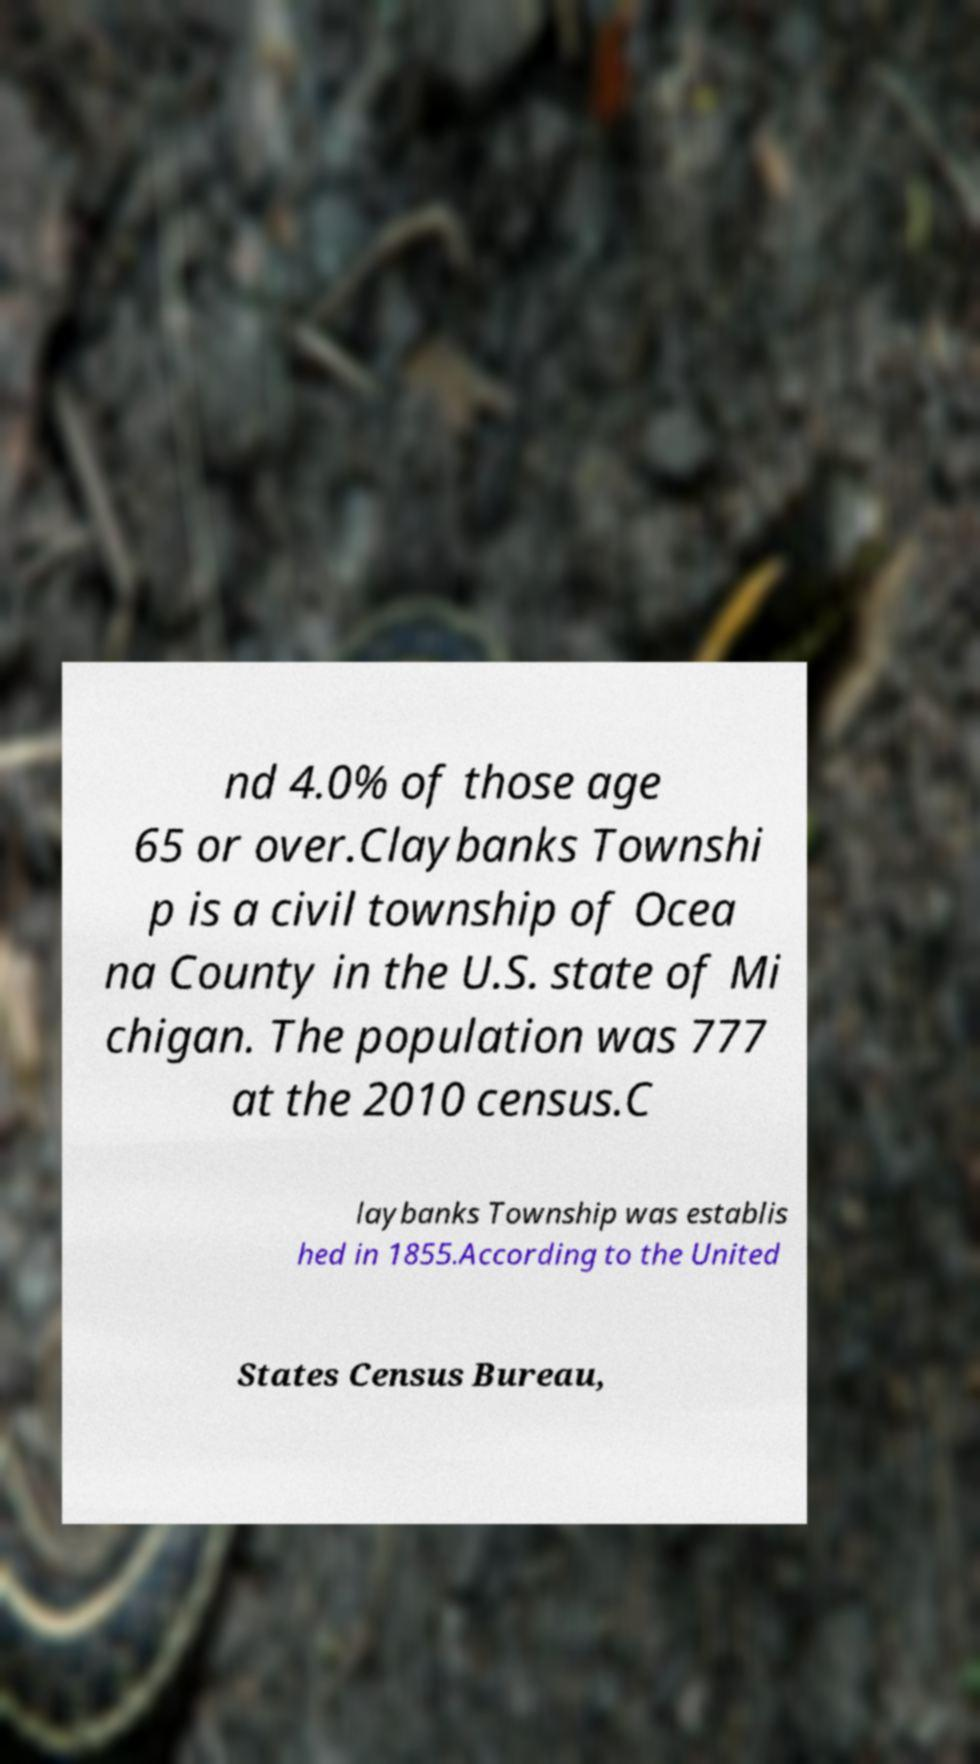For documentation purposes, I need the text within this image transcribed. Could you provide that? nd 4.0% of those age 65 or over.Claybanks Townshi p is a civil township of Ocea na County in the U.S. state of Mi chigan. The population was 777 at the 2010 census.C laybanks Township was establis hed in 1855.According to the United States Census Bureau, 